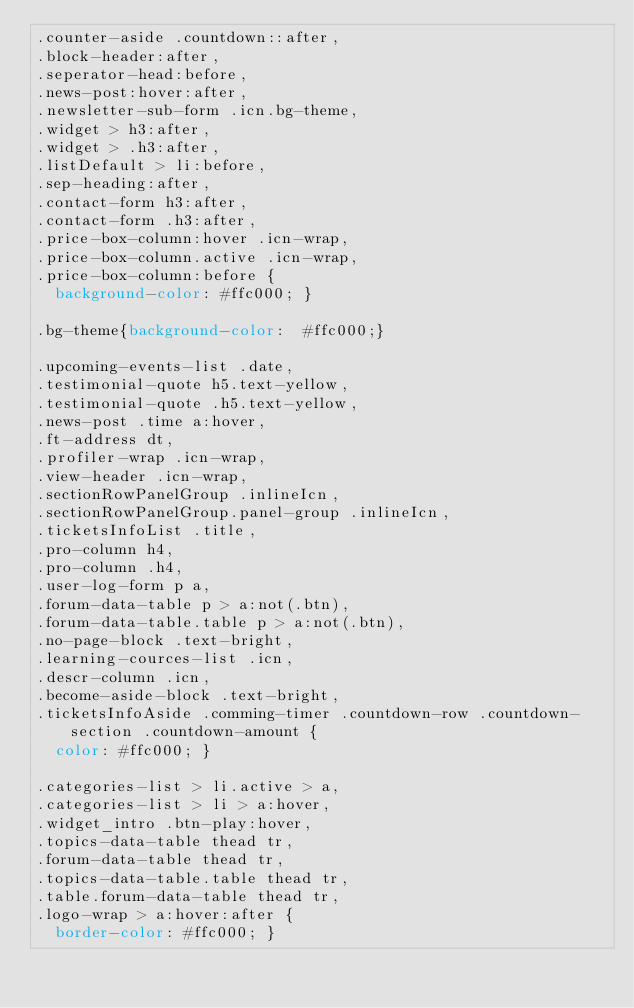<code> <loc_0><loc_0><loc_500><loc_500><_CSS_>.counter-aside .countdown::after,
.block-header:after,
.seperator-head:before,
.news-post:hover:after,
.newsletter-sub-form .icn.bg-theme,
.widget > h3:after,
.widget > .h3:after,
.listDefault > li:before,
.sep-heading:after,
.contact-form h3:after,
.contact-form .h3:after,
.price-box-column:hover .icn-wrap,
.price-box-column.active .icn-wrap,
.price-box-column:before {
  background-color: #ffc000; }

.bg-theme{background-color:  #ffc000;}

.upcoming-events-list .date,
.testimonial-quote h5.text-yellow,
.testimonial-quote .h5.text-yellow,
.news-post .time a:hover,
.ft-address dt,
.profiler-wrap .icn-wrap,
.view-header .icn-wrap,
.sectionRowPanelGroup .inlineIcn,
.sectionRowPanelGroup.panel-group .inlineIcn,
.ticketsInfoList .title,
.pro-column h4,
.pro-column .h4,
.user-log-form p a,
.forum-data-table p > a:not(.btn),
.forum-data-table.table p > a:not(.btn),
.no-page-block .text-bright,
.learning-cources-list .icn,
.descr-column .icn,
.become-aside-block .text-bright,
.ticketsInfoAside .comming-timer .countdown-row .countdown-section .countdown-amount {
  color: #ffc000; }

.categories-list > li.active > a,
.categories-list > li > a:hover,
.widget_intro .btn-play:hover,
.topics-data-table thead tr,
.forum-data-table thead tr,
.topics-data-table.table thead tr,
.table.forum-data-table thead tr,
.logo-wrap > a:hover:after {
  border-color: #ffc000; }
</code> 